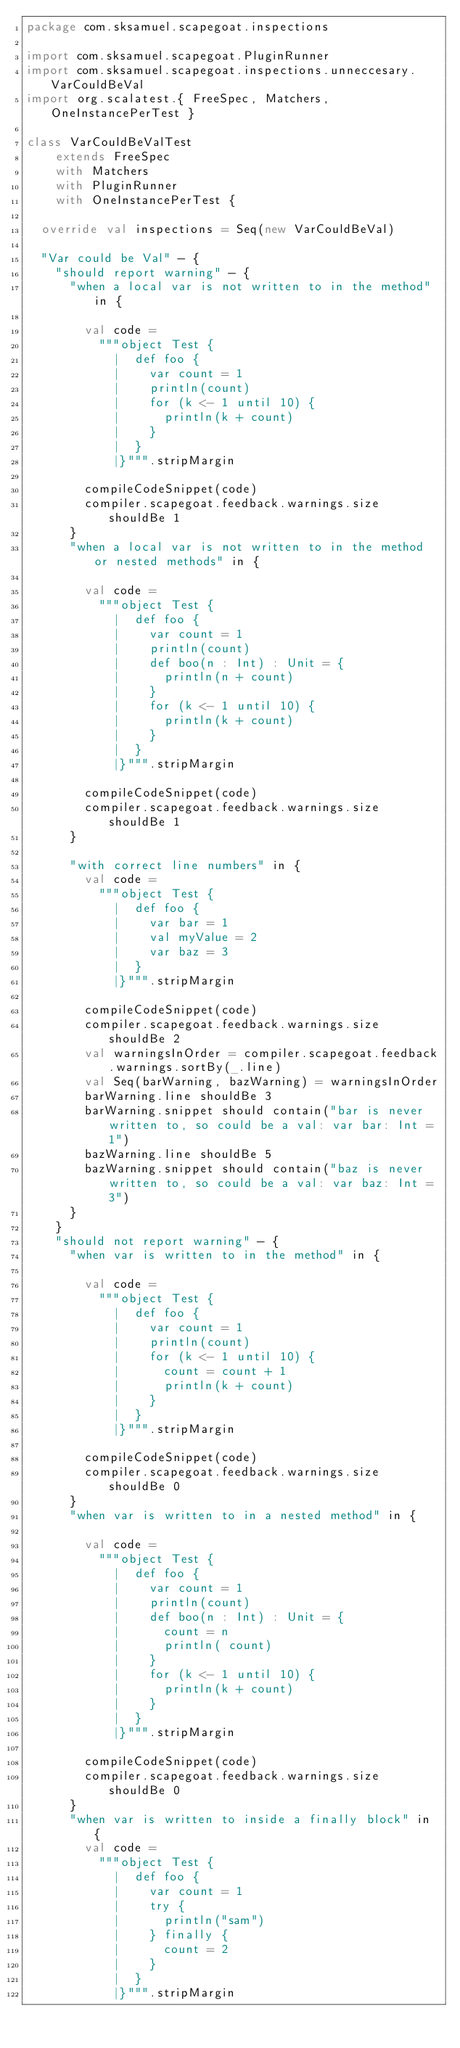Convert code to text. <code><loc_0><loc_0><loc_500><loc_500><_Scala_>package com.sksamuel.scapegoat.inspections

import com.sksamuel.scapegoat.PluginRunner
import com.sksamuel.scapegoat.inspections.unneccesary.VarCouldBeVal
import org.scalatest.{ FreeSpec, Matchers, OneInstancePerTest }

class VarCouldBeValTest
    extends FreeSpec
    with Matchers
    with PluginRunner
    with OneInstancePerTest {

  override val inspections = Seq(new VarCouldBeVal)

  "Var could be Val" - {
    "should report warning" - {
      "when a local var is not written to in the method" in {

        val code =
          """object Test {
            |  def foo {
            |    var count = 1
            |    println(count)
            |    for (k <- 1 until 10) {
            |      println(k + count)
            |    }
            |  }
            |}""".stripMargin

        compileCodeSnippet(code)
        compiler.scapegoat.feedback.warnings.size shouldBe 1
      }
      "when a local var is not written to in the method or nested methods" in {

        val code =
          """object Test {
            |  def foo {
            |    var count = 1
            |    println(count)
            |    def boo(n : Int) : Unit = {
            |      println(n + count)
            |    }
            |    for (k <- 1 until 10) {
            |      println(k + count)
            |    }
            |  }
            |}""".stripMargin

        compileCodeSnippet(code)
        compiler.scapegoat.feedback.warnings.size shouldBe 1
      }

      "with correct line numbers" in {
        val code =
          """object Test {
            |  def foo {
            |    var bar = 1
            |    val myValue = 2
            |    var baz = 3
            |  }
            |}""".stripMargin

        compileCodeSnippet(code)
        compiler.scapegoat.feedback.warnings.size shouldBe 2
        val warningsInOrder = compiler.scapegoat.feedback.warnings.sortBy(_.line)
        val Seq(barWarning, bazWarning) = warningsInOrder
        barWarning.line shouldBe 3
        barWarning.snippet should contain("bar is never written to, so could be a val: var bar: Int = 1")
        bazWarning.line shouldBe 5
        bazWarning.snippet should contain("baz is never written to, so could be a val: var baz: Int = 3")
      }
    }
    "should not report warning" - {
      "when var is written to in the method" in {

        val code =
          """object Test {
            |  def foo {
            |    var count = 1
            |    println(count)
            |    for (k <- 1 until 10) {
            |      count = count + 1
            |      println(k + count)
            |    }
            |  }
            |}""".stripMargin

        compileCodeSnippet(code)
        compiler.scapegoat.feedback.warnings.size shouldBe 0
      }
      "when var is written to in a nested method" in {

        val code =
          """object Test {
            |  def foo {
            |    var count = 1
            |    println(count)
            |    def boo(n : Int) : Unit = {
            |      count = n
            |      println( count)
            |    }
            |    for (k <- 1 until 10) {
            |      println(k + count)
            |    }
            |  }
            |}""".stripMargin

        compileCodeSnippet(code)
        compiler.scapegoat.feedback.warnings.size shouldBe 0
      }
      "when var is written to inside a finally block" in {
        val code =
          """object Test {
            |  def foo {
            |    var count = 1
            |    try {
            |      println("sam")
            |    } finally {
            |      count = 2
            |    }
            |  }
            |}""".stripMargin
</code> 